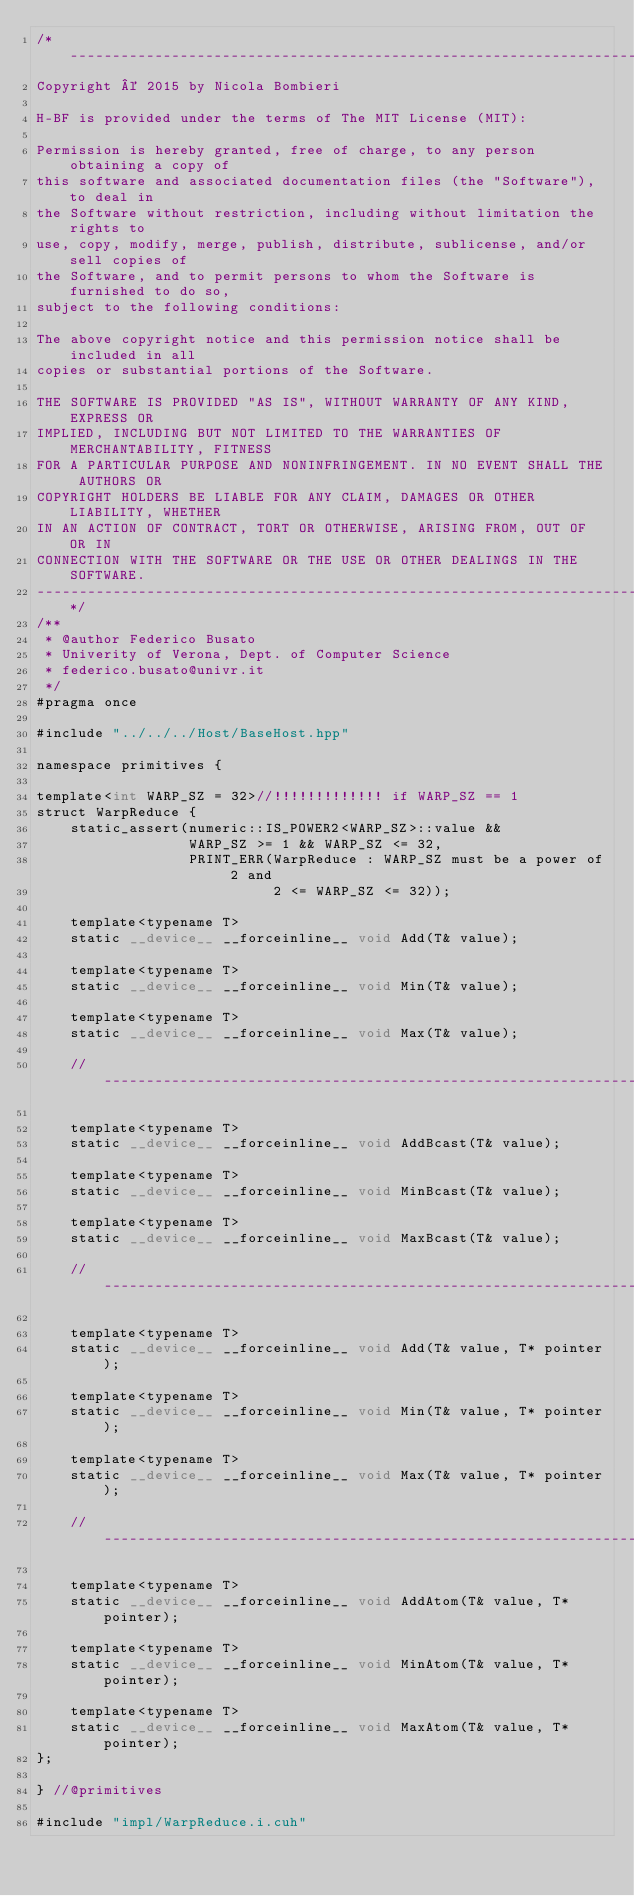Convert code to text. <code><loc_0><loc_0><loc_500><loc_500><_Cuda_>/*------------------------------------------------------------------------------
Copyright © 2015 by Nicola Bombieri

H-BF is provided under the terms of The MIT License (MIT):

Permission is hereby granted, free of charge, to any person obtaining a copy of
this software and associated documentation files (the "Software"), to deal in
the Software without restriction, including without limitation the rights to
use, copy, modify, merge, publish, distribute, sublicense, and/or sell copies of
the Software, and to permit persons to whom the Software is furnished to do so,
subject to the following conditions:

The above copyright notice and this permission notice shall be included in all
copies or substantial portions of the Software.

THE SOFTWARE IS PROVIDED "AS IS", WITHOUT WARRANTY OF ANY KIND, EXPRESS OR
IMPLIED, INCLUDING BUT NOT LIMITED TO THE WARRANTIES OF MERCHANTABILITY, FITNESS
FOR A PARTICULAR PURPOSE AND NONINFRINGEMENT. IN NO EVENT SHALL THE AUTHORS OR
COPYRIGHT HOLDERS BE LIABLE FOR ANY CLAIM, DAMAGES OR OTHER LIABILITY, WHETHER
IN AN ACTION OF CONTRACT, TORT OR OTHERWISE, ARISING FROM, OUT OF OR IN
CONNECTION WITH THE SOFTWARE OR THE USE OR OTHER DEALINGS IN THE SOFTWARE.
------------------------------------------------------------------------------*/
/**
 * @author Federico Busato
 * Univerity of Verona, Dept. of Computer Science
 * federico.busato@univr.it
 */
#pragma once

#include "../../../Host/BaseHost.hpp"

namespace primitives {

template<int WARP_SZ = 32>//!!!!!!!!!!!!! if WARP_SZ == 1
struct WarpReduce {
    static_assert(numeric::IS_POWER2<WARP_SZ>::value &&
                  WARP_SZ >= 1 && WARP_SZ <= 32,
                  PRINT_ERR(WarpReduce : WARP_SZ must be a power of 2 and
                            2 <= WARP_SZ <= 32));

    template<typename T>
    static __device__ __forceinline__ void Add(T& value);

    template<typename T>
    static __device__ __forceinline__ void Min(T& value);

    template<typename T>
    static __device__ __forceinline__ void Max(T& value);

    //--------------------------------------------------------------------------

    template<typename T>
    static __device__ __forceinline__ void AddBcast(T& value);

    template<typename T>
    static __device__ __forceinline__ void MinBcast(T& value);

    template<typename T>
    static __device__ __forceinline__ void MaxBcast(T& value);

    //--------------------------------------------------------------------------

    template<typename T>
    static __device__ __forceinline__ void Add(T& value, T* pointer);

    template<typename T>
    static __device__ __forceinline__ void Min(T& value, T* pointer);

    template<typename T>
    static __device__ __forceinline__ void Max(T& value, T* pointer);

    //--------------------------------------------------------------------------

    template<typename T>
    static __device__ __forceinline__ void AddAtom(T& value, T* pointer);

    template<typename T>
    static __device__ __forceinline__ void MinAtom(T& value, T* pointer);

    template<typename T>
    static __device__ __forceinline__ void MaxAtom(T& value, T* pointer);
};

} //@primitives

#include "impl/WarpReduce.i.cuh"
</code> 